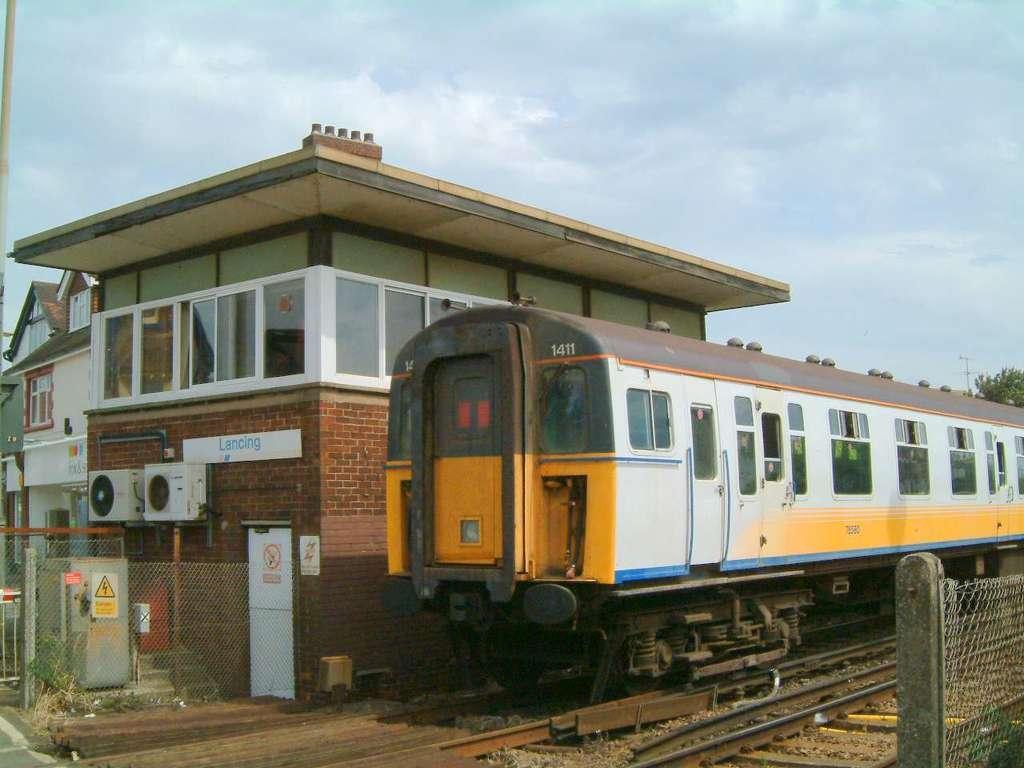Can you describe this image briefly? In the picture we can see a train on the railway track, just beside to it, we can see a fencing wall with poles and on the other side, we can see a station building with a glass windows and a door to it which is white in color and also we can see some fencing near it and in the background we can see some tree and sky with clouds. 